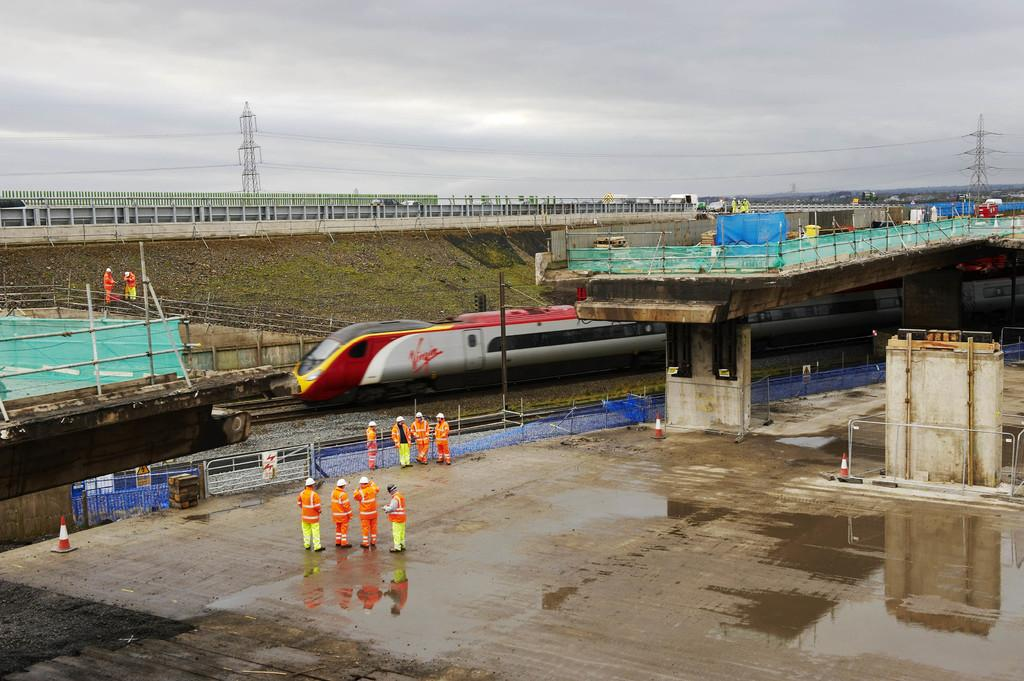<image>
Relay a brief, clear account of the picture shown. A Virgin train pulls into a platform at the station. 